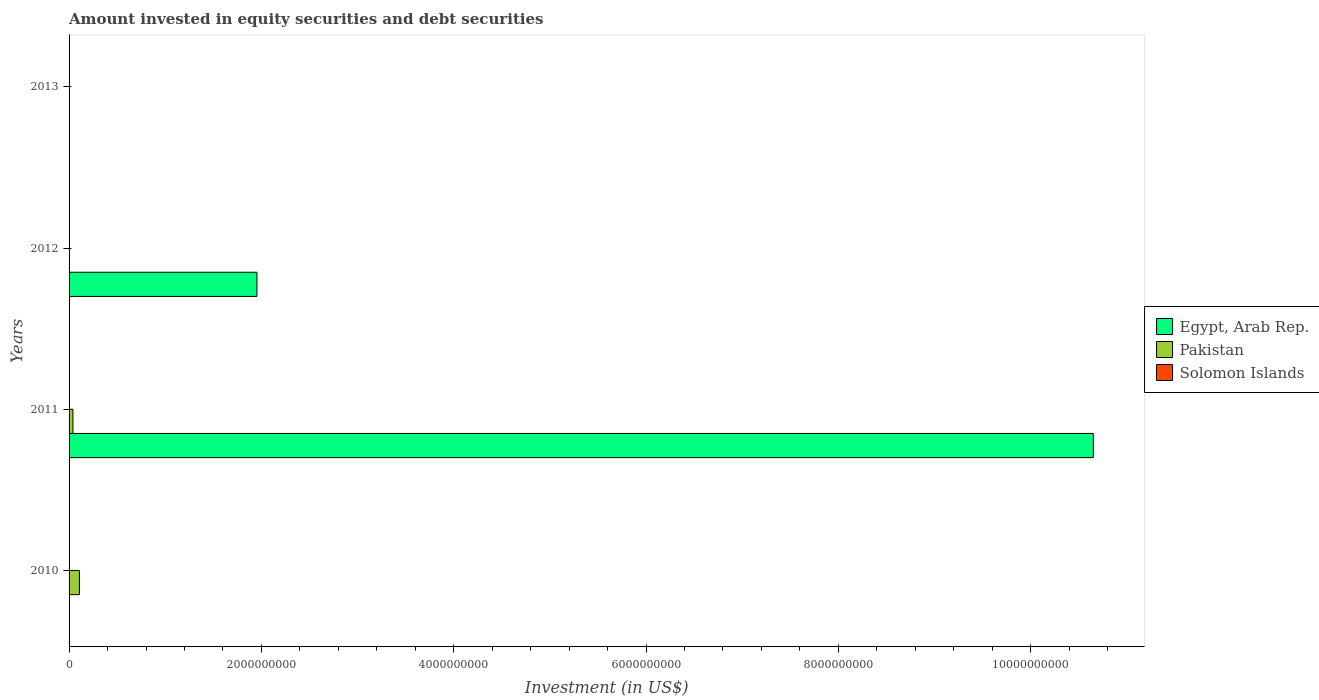How many different coloured bars are there?
Your answer should be compact. 3. Are the number of bars per tick equal to the number of legend labels?
Give a very brief answer. No. Are the number of bars on each tick of the Y-axis equal?
Give a very brief answer. No. How many bars are there on the 4th tick from the bottom?
Make the answer very short. 0. Across all years, what is the maximum amount invested in equity securities and debt securities in Pakistan?
Give a very brief answer. 1.08e+08. What is the total amount invested in equity securities and debt securities in Egypt, Arab Rep. in the graph?
Give a very brief answer. 1.26e+1. What is the difference between the amount invested in equity securities and debt securities in Solomon Islands in 2010 and that in 2012?
Offer a terse response. -6.40e+05. What is the difference between the amount invested in equity securities and debt securities in Pakistan in 2011 and the amount invested in equity securities and debt securities in Solomon Islands in 2012?
Offer a very short reply. 3.67e+07. What is the average amount invested in equity securities and debt securities in Pakistan per year?
Your answer should be compact. 3.70e+07. In the year 2010, what is the difference between the amount invested in equity securities and debt securities in Solomon Islands and amount invested in equity securities and debt securities in Pakistan?
Your answer should be compact. -1.05e+08. In how many years, is the amount invested in equity securities and debt securities in Pakistan greater than 6000000000 US$?
Provide a succinct answer. 0. What is the difference between the highest and the lowest amount invested in equity securities and debt securities in Pakistan?
Give a very brief answer. 1.08e+08. In how many years, is the amount invested in equity securities and debt securities in Pakistan greater than the average amount invested in equity securities and debt securities in Pakistan taken over all years?
Give a very brief answer. 2. Is the sum of the amount invested in equity securities and debt securities in Egypt, Arab Rep. in 2011 and 2012 greater than the maximum amount invested in equity securities and debt securities in Pakistan across all years?
Your answer should be compact. Yes. Is it the case that in every year, the sum of the amount invested in equity securities and debt securities in Solomon Islands and amount invested in equity securities and debt securities in Egypt, Arab Rep. is greater than the amount invested in equity securities and debt securities in Pakistan?
Your answer should be very brief. No. How many bars are there?
Make the answer very short. 6. Are all the bars in the graph horizontal?
Ensure brevity in your answer.  Yes. Are the values on the major ticks of X-axis written in scientific E-notation?
Offer a terse response. No. Does the graph contain grids?
Your answer should be compact. No. What is the title of the graph?
Your response must be concise. Amount invested in equity securities and debt securities. What is the label or title of the X-axis?
Ensure brevity in your answer.  Investment (in US$). What is the label or title of the Y-axis?
Make the answer very short. Years. What is the Investment (in US$) in Pakistan in 2010?
Ensure brevity in your answer.  1.08e+08. What is the Investment (in US$) in Solomon Islands in 2010?
Your answer should be very brief. 2.65e+06. What is the Investment (in US$) of Egypt, Arab Rep. in 2011?
Offer a very short reply. 1.07e+1. What is the Investment (in US$) of Pakistan in 2011?
Your response must be concise. 4.00e+07. What is the Investment (in US$) in Egypt, Arab Rep. in 2012?
Make the answer very short. 1.95e+09. What is the Investment (in US$) in Pakistan in 2012?
Give a very brief answer. 0. What is the Investment (in US$) in Solomon Islands in 2012?
Make the answer very short. 3.29e+06. What is the Investment (in US$) of Egypt, Arab Rep. in 2013?
Provide a succinct answer. 0. What is the Investment (in US$) of Solomon Islands in 2013?
Keep it short and to the point. 0. Across all years, what is the maximum Investment (in US$) in Egypt, Arab Rep.?
Your answer should be very brief. 1.07e+1. Across all years, what is the maximum Investment (in US$) in Pakistan?
Make the answer very short. 1.08e+08. Across all years, what is the maximum Investment (in US$) in Solomon Islands?
Offer a terse response. 3.29e+06. Across all years, what is the minimum Investment (in US$) of Egypt, Arab Rep.?
Keep it short and to the point. 0. What is the total Investment (in US$) in Egypt, Arab Rep. in the graph?
Offer a terse response. 1.26e+1. What is the total Investment (in US$) in Pakistan in the graph?
Provide a succinct answer. 1.48e+08. What is the total Investment (in US$) in Solomon Islands in the graph?
Give a very brief answer. 5.94e+06. What is the difference between the Investment (in US$) of Pakistan in 2010 and that in 2011?
Your answer should be very brief. 6.80e+07. What is the difference between the Investment (in US$) in Solomon Islands in 2010 and that in 2012?
Ensure brevity in your answer.  -6.40e+05. What is the difference between the Investment (in US$) of Egypt, Arab Rep. in 2011 and that in 2012?
Keep it short and to the point. 8.70e+09. What is the difference between the Investment (in US$) in Pakistan in 2010 and the Investment (in US$) in Solomon Islands in 2012?
Make the answer very short. 1.05e+08. What is the difference between the Investment (in US$) in Egypt, Arab Rep. in 2011 and the Investment (in US$) in Solomon Islands in 2012?
Make the answer very short. 1.06e+1. What is the difference between the Investment (in US$) of Pakistan in 2011 and the Investment (in US$) of Solomon Islands in 2012?
Ensure brevity in your answer.  3.67e+07. What is the average Investment (in US$) of Egypt, Arab Rep. per year?
Make the answer very short. 3.15e+09. What is the average Investment (in US$) of Pakistan per year?
Provide a succinct answer. 3.70e+07. What is the average Investment (in US$) of Solomon Islands per year?
Offer a very short reply. 1.48e+06. In the year 2010, what is the difference between the Investment (in US$) of Pakistan and Investment (in US$) of Solomon Islands?
Your answer should be very brief. 1.05e+08. In the year 2011, what is the difference between the Investment (in US$) in Egypt, Arab Rep. and Investment (in US$) in Pakistan?
Ensure brevity in your answer.  1.06e+1. In the year 2012, what is the difference between the Investment (in US$) in Egypt, Arab Rep. and Investment (in US$) in Solomon Islands?
Give a very brief answer. 1.95e+09. What is the ratio of the Investment (in US$) in Pakistan in 2010 to that in 2011?
Make the answer very short. 2.7. What is the ratio of the Investment (in US$) of Solomon Islands in 2010 to that in 2012?
Your response must be concise. 0.81. What is the ratio of the Investment (in US$) in Egypt, Arab Rep. in 2011 to that in 2012?
Keep it short and to the point. 5.45. What is the difference between the highest and the lowest Investment (in US$) of Egypt, Arab Rep.?
Your answer should be very brief. 1.07e+1. What is the difference between the highest and the lowest Investment (in US$) of Pakistan?
Offer a terse response. 1.08e+08. What is the difference between the highest and the lowest Investment (in US$) in Solomon Islands?
Offer a terse response. 3.29e+06. 